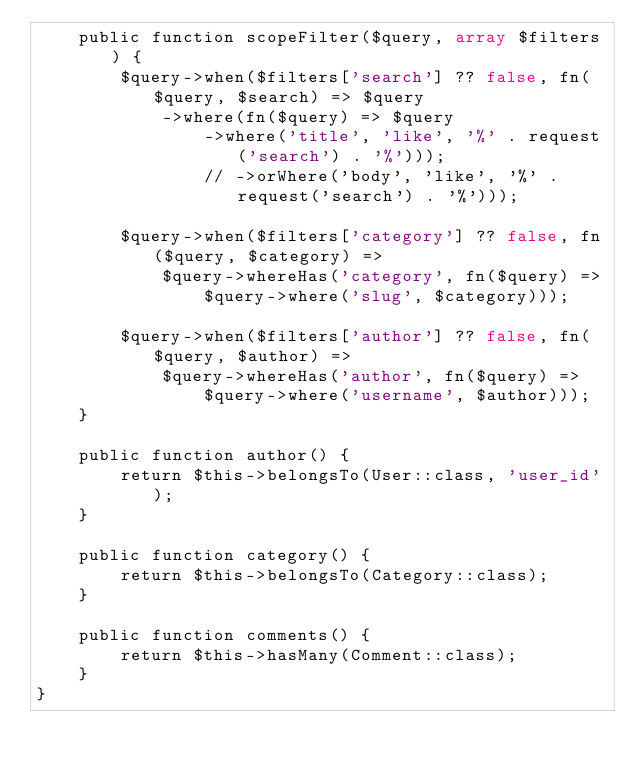Convert code to text. <code><loc_0><loc_0><loc_500><loc_500><_PHP_>    public function scopeFilter($query, array $filters) {
        $query->when($filters['search'] ?? false, fn($query, $search) => $query
            ->where(fn($query) => $query
                ->where('title', 'like', '%' . request('search') . '%')));
                // ->orWhere('body', 'like', '%' . request('search') . '%')));

        $query->when($filters['category'] ?? false, fn($query, $category) =>
            $query->whereHas('category', fn($query) =>
                $query->where('slug', $category)));

        $query->when($filters['author'] ?? false, fn($query, $author) =>
            $query->whereHas('author', fn($query) =>
                $query->where('username', $author)));
    }

    public function author() {
        return $this->belongsTo(User::class, 'user_id');
    }

    public function category() {
        return $this->belongsTo(Category::class);
    }

    public function comments() {
        return $this->hasMany(Comment::class);
    }
}
</code> 